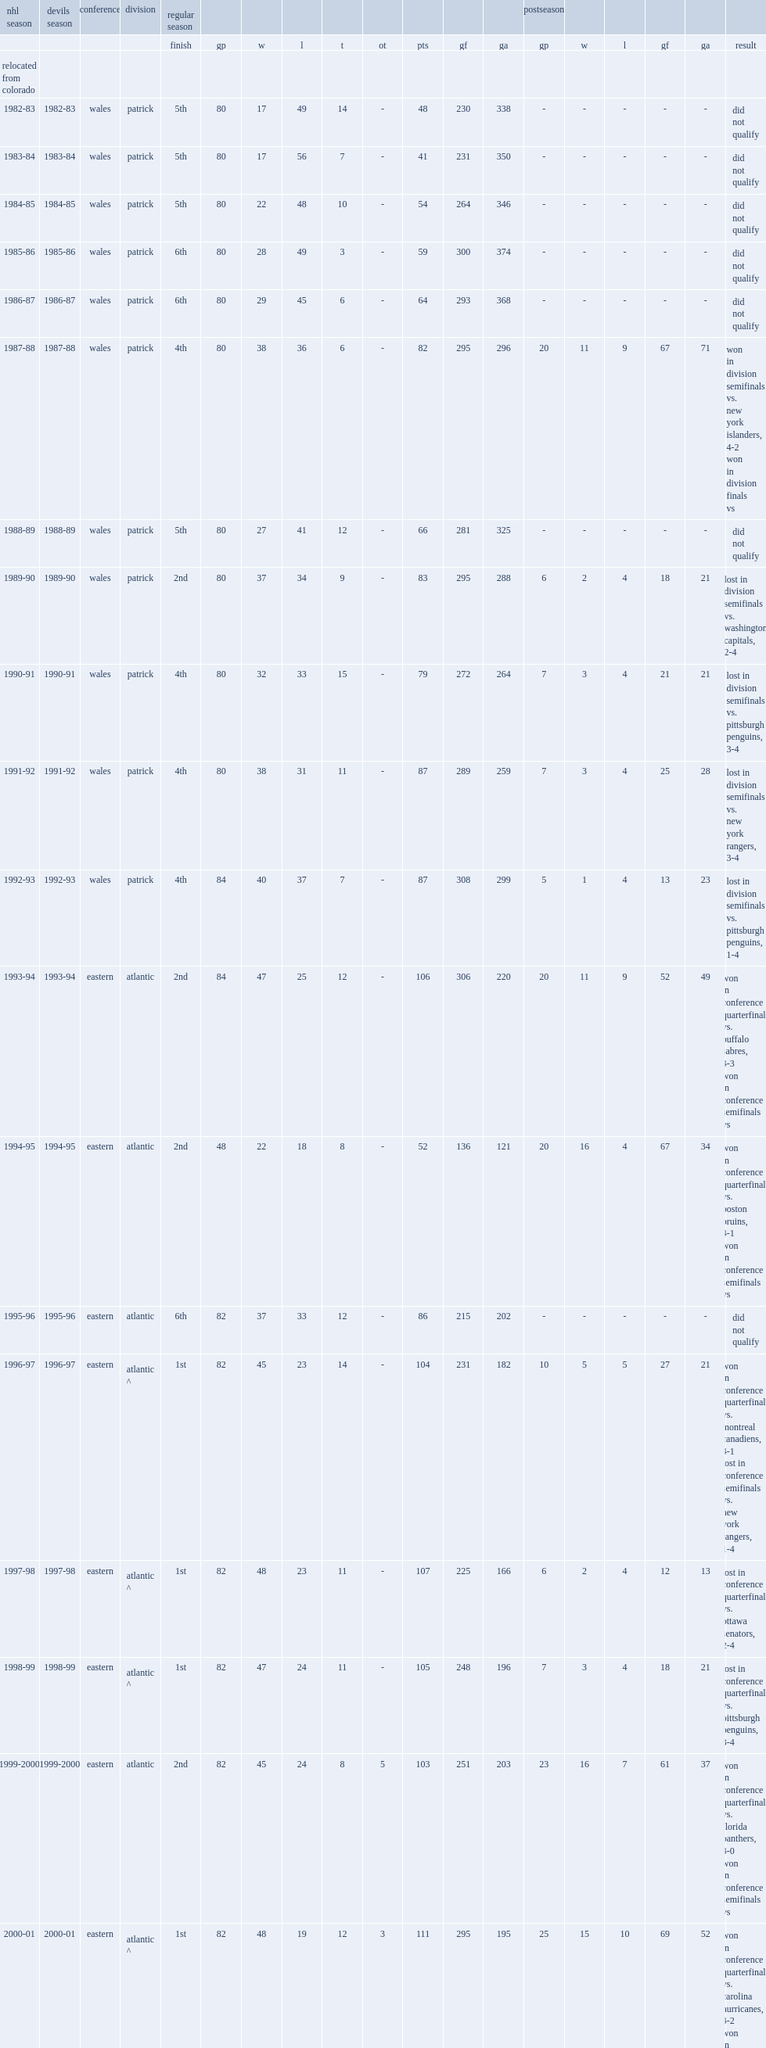Which period was new jersey devils team's fifth season? 1986-87. 